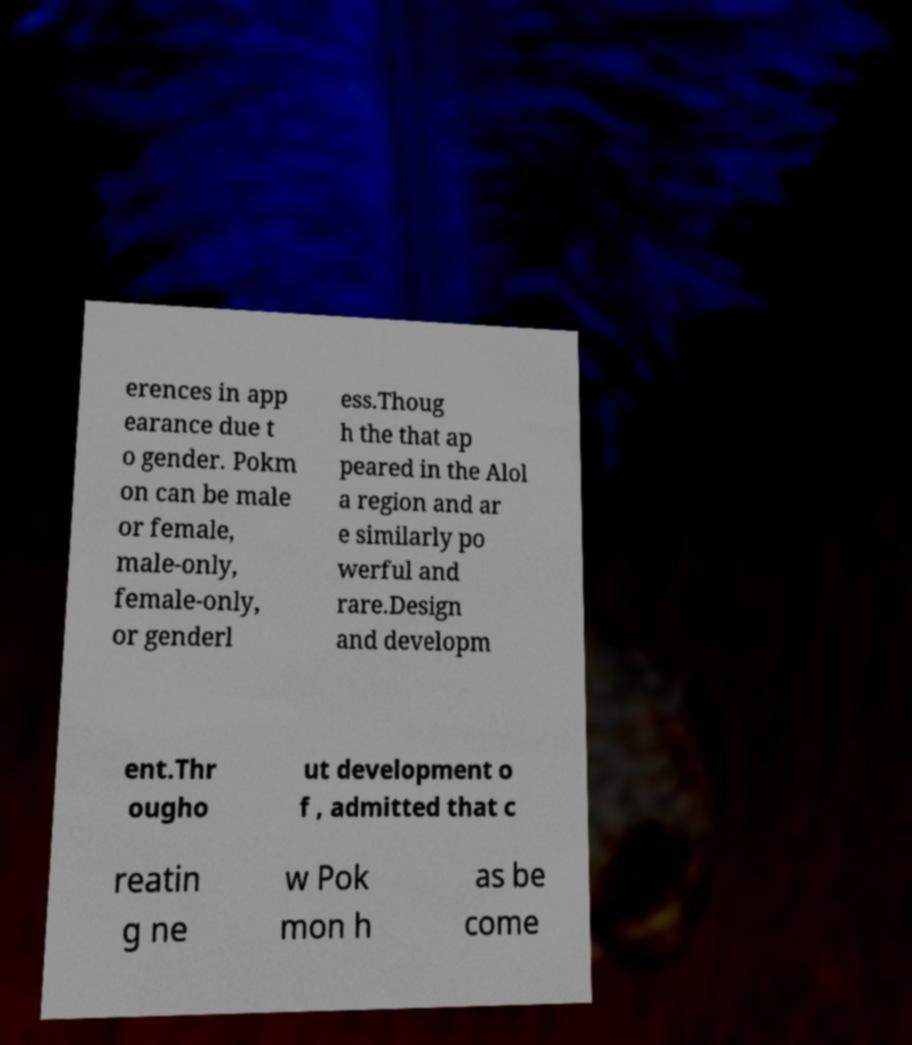What messages or text are displayed in this image? I need them in a readable, typed format. erences in app earance due t o gender. Pokm on can be male or female, male-only, female-only, or genderl ess.Thoug h the that ap peared in the Alol a region and ar e similarly po werful and rare.Design and developm ent.Thr ougho ut development o f , admitted that c reatin g ne w Pok mon h as be come 